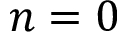<formula> <loc_0><loc_0><loc_500><loc_500>n = 0</formula> 